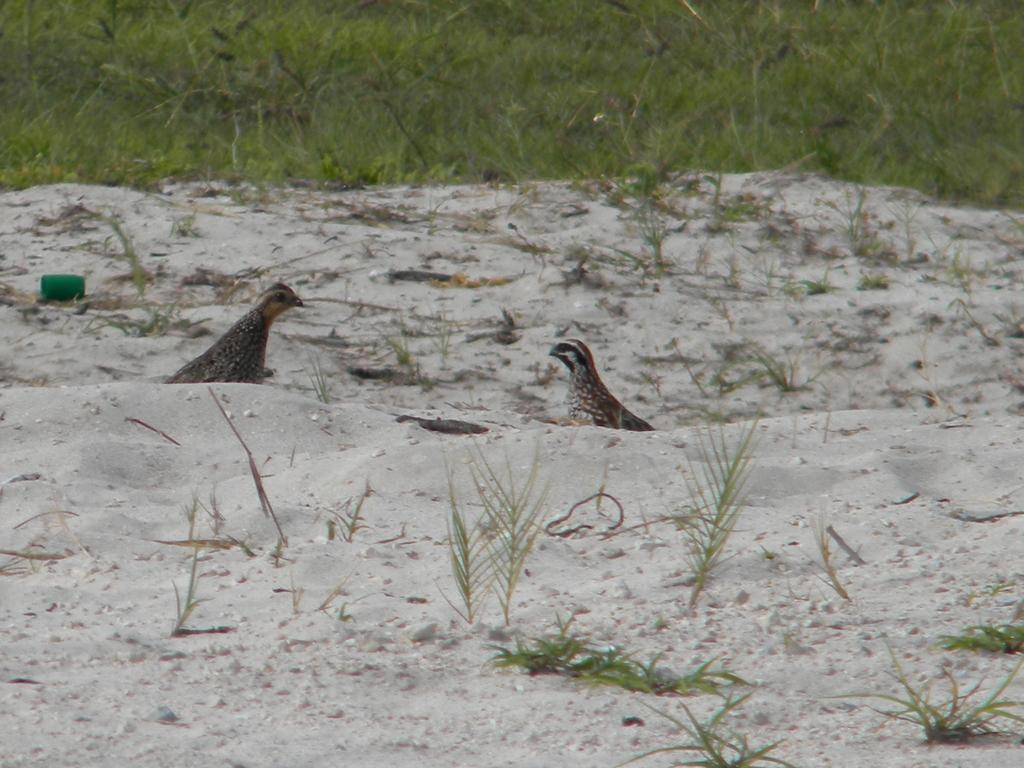How many birds can be seen in the image? There are two birds in the image. What type of surface is visible beneath the birds? The ground is visible in the image. What type of vegetation is present in the image? There are plants and grass in the image. What color dominates the top part of the image? The top of the image has a green color view. Where is the lumber being stored in the image? There is no lumber present in the image. Can you see any goldfish swimming in the image? There are no goldfish present in the image. 